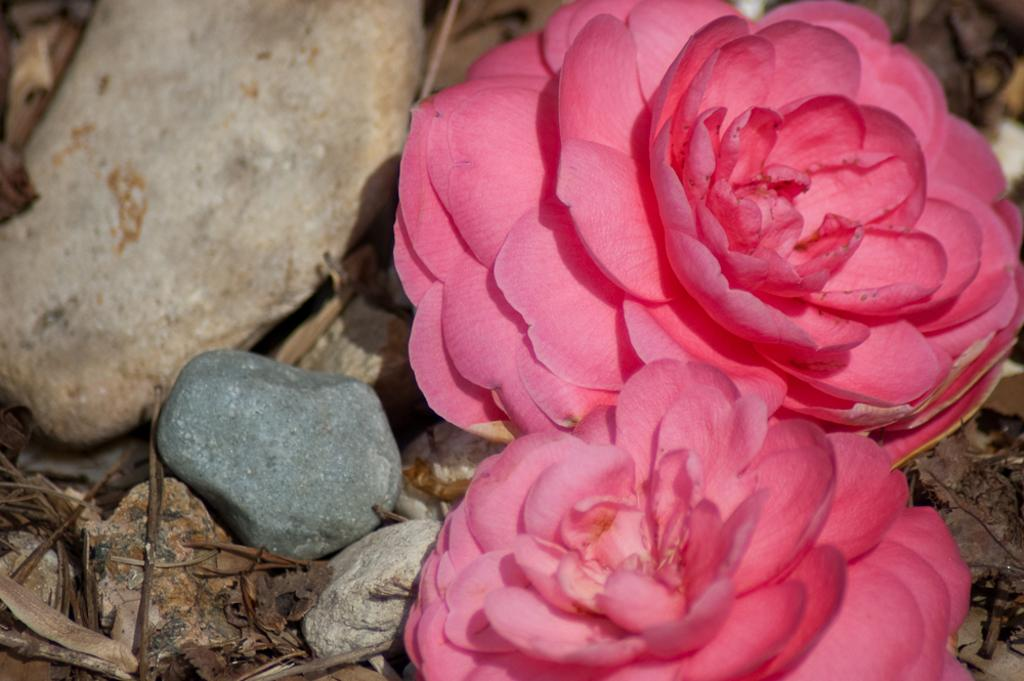What type of vegetation can be seen on the right side of the image? There are flowers on the right side of the image. What else is present in the image besides the flowers? There are stones in the image. What type of lettuce can be seen growing in the image? There is no lettuce present in the image; it features flowers and stones. Can you tell me how much sand is visible in the image? There is no sand present in the image. 